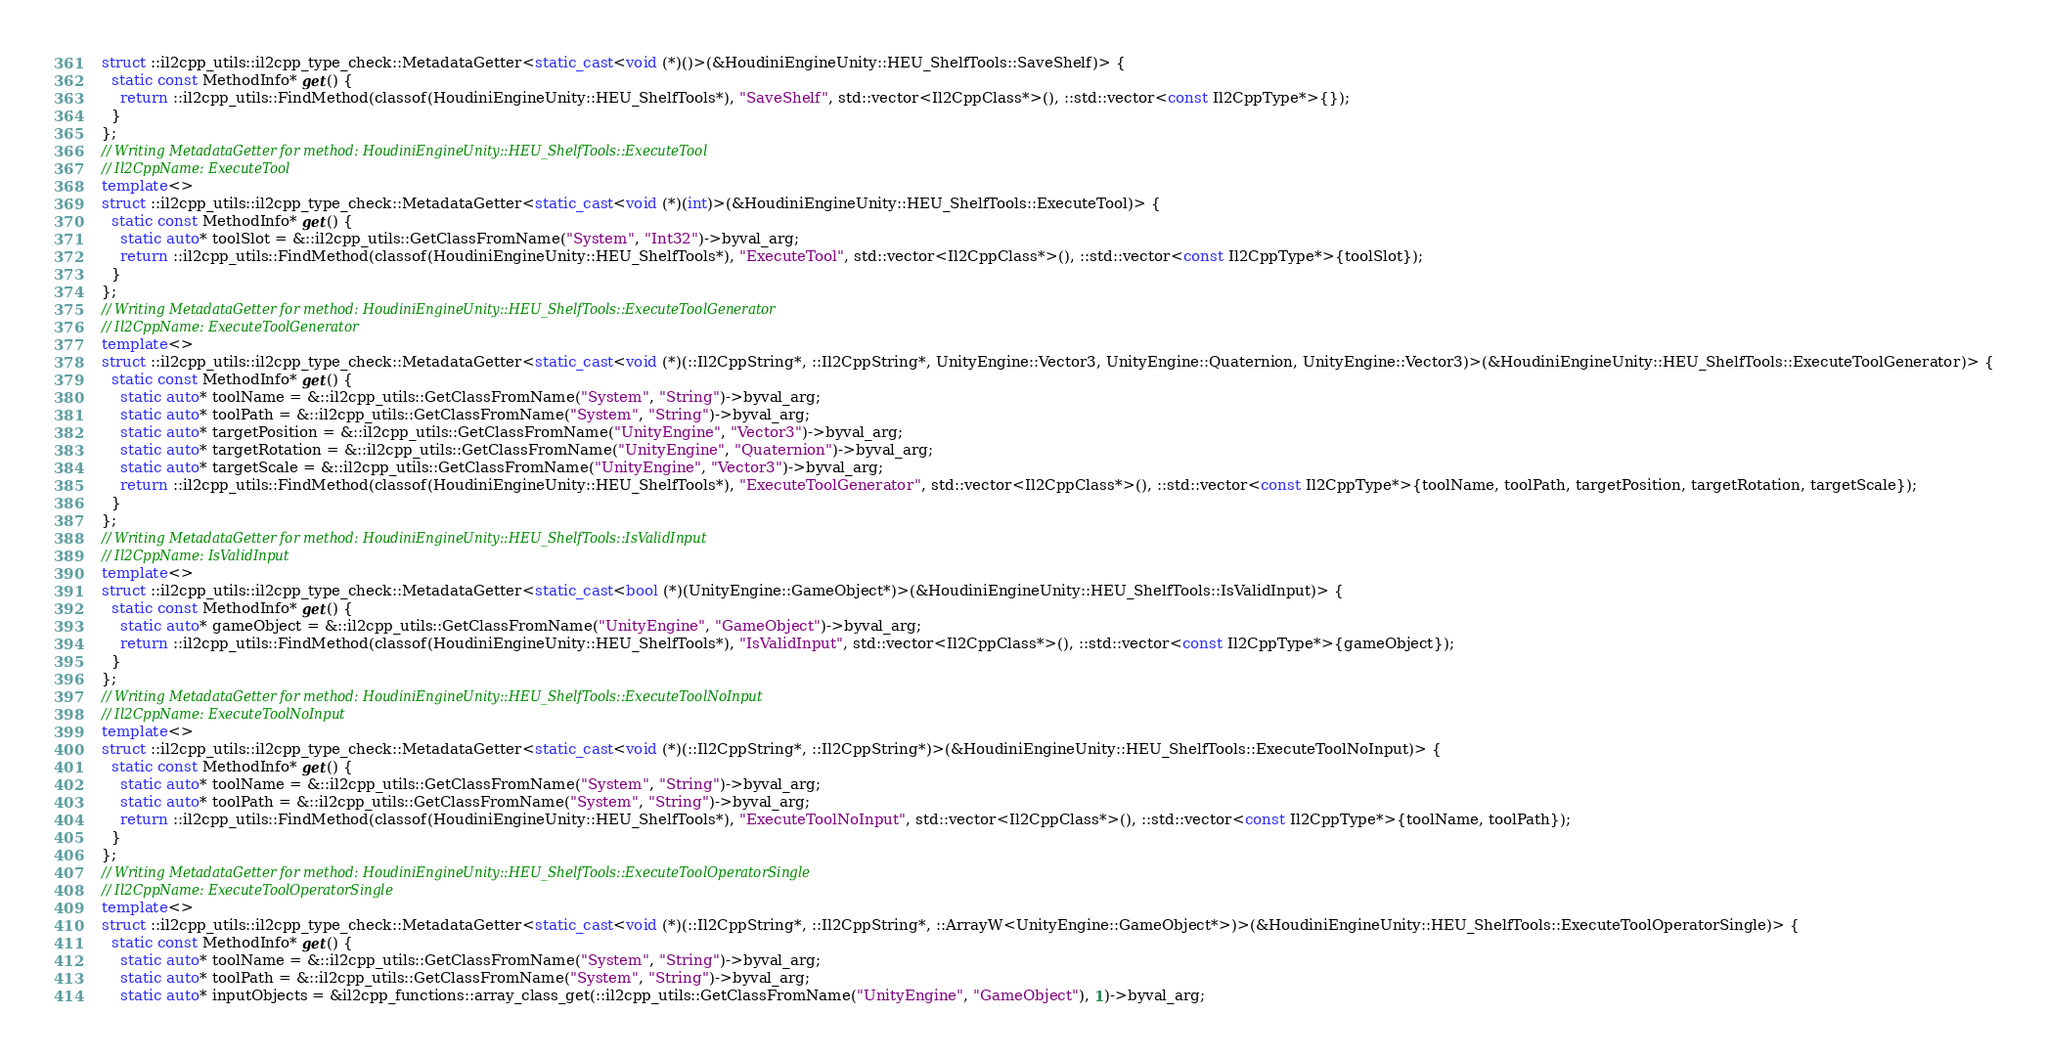<code> <loc_0><loc_0><loc_500><loc_500><_C++_>struct ::il2cpp_utils::il2cpp_type_check::MetadataGetter<static_cast<void (*)()>(&HoudiniEngineUnity::HEU_ShelfTools::SaveShelf)> {
  static const MethodInfo* get() {
    return ::il2cpp_utils::FindMethod(classof(HoudiniEngineUnity::HEU_ShelfTools*), "SaveShelf", std::vector<Il2CppClass*>(), ::std::vector<const Il2CppType*>{});
  }
};
// Writing MetadataGetter for method: HoudiniEngineUnity::HEU_ShelfTools::ExecuteTool
// Il2CppName: ExecuteTool
template<>
struct ::il2cpp_utils::il2cpp_type_check::MetadataGetter<static_cast<void (*)(int)>(&HoudiniEngineUnity::HEU_ShelfTools::ExecuteTool)> {
  static const MethodInfo* get() {
    static auto* toolSlot = &::il2cpp_utils::GetClassFromName("System", "Int32")->byval_arg;
    return ::il2cpp_utils::FindMethod(classof(HoudiniEngineUnity::HEU_ShelfTools*), "ExecuteTool", std::vector<Il2CppClass*>(), ::std::vector<const Il2CppType*>{toolSlot});
  }
};
// Writing MetadataGetter for method: HoudiniEngineUnity::HEU_ShelfTools::ExecuteToolGenerator
// Il2CppName: ExecuteToolGenerator
template<>
struct ::il2cpp_utils::il2cpp_type_check::MetadataGetter<static_cast<void (*)(::Il2CppString*, ::Il2CppString*, UnityEngine::Vector3, UnityEngine::Quaternion, UnityEngine::Vector3)>(&HoudiniEngineUnity::HEU_ShelfTools::ExecuteToolGenerator)> {
  static const MethodInfo* get() {
    static auto* toolName = &::il2cpp_utils::GetClassFromName("System", "String")->byval_arg;
    static auto* toolPath = &::il2cpp_utils::GetClassFromName("System", "String")->byval_arg;
    static auto* targetPosition = &::il2cpp_utils::GetClassFromName("UnityEngine", "Vector3")->byval_arg;
    static auto* targetRotation = &::il2cpp_utils::GetClassFromName("UnityEngine", "Quaternion")->byval_arg;
    static auto* targetScale = &::il2cpp_utils::GetClassFromName("UnityEngine", "Vector3")->byval_arg;
    return ::il2cpp_utils::FindMethod(classof(HoudiniEngineUnity::HEU_ShelfTools*), "ExecuteToolGenerator", std::vector<Il2CppClass*>(), ::std::vector<const Il2CppType*>{toolName, toolPath, targetPosition, targetRotation, targetScale});
  }
};
// Writing MetadataGetter for method: HoudiniEngineUnity::HEU_ShelfTools::IsValidInput
// Il2CppName: IsValidInput
template<>
struct ::il2cpp_utils::il2cpp_type_check::MetadataGetter<static_cast<bool (*)(UnityEngine::GameObject*)>(&HoudiniEngineUnity::HEU_ShelfTools::IsValidInput)> {
  static const MethodInfo* get() {
    static auto* gameObject = &::il2cpp_utils::GetClassFromName("UnityEngine", "GameObject")->byval_arg;
    return ::il2cpp_utils::FindMethod(classof(HoudiniEngineUnity::HEU_ShelfTools*), "IsValidInput", std::vector<Il2CppClass*>(), ::std::vector<const Il2CppType*>{gameObject});
  }
};
// Writing MetadataGetter for method: HoudiniEngineUnity::HEU_ShelfTools::ExecuteToolNoInput
// Il2CppName: ExecuteToolNoInput
template<>
struct ::il2cpp_utils::il2cpp_type_check::MetadataGetter<static_cast<void (*)(::Il2CppString*, ::Il2CppString*)>(&HoudiniEngineUnity::HEU_ShelfTools::ExecuteToolNoInput)> {
  static const MethodInfo* get() {
    static auto* toolName = &::il2cpp_utils::GetClassFromName("System", "String")->byval_arg;
    static auto* toolPath = &::il2cpp_utils::GetClassFromName("System", "String")->byval_arg;
    return ::il2cpp_utils::FindMethod(classof(HoudiniEngineUnity::HEU_ShelfTools*), "ExecuteToolNoInput", std::vector<Il2CppClass*>(), ::std::vector<const Il2CppType*>{toolName, toolPath});
  }
};
// Writing MetadataGetter for method: HoudiniEngineUnity::HEU_ShelfTools::ExecuteToolOperatorSingle
// Il2CppName: ExecuteToolOperatorSingle
template<>
struct ::il2cpp_utils::il2cpp_type_check::MetadataGetter<static_cast<void (*)(::Il2CppString*, ::Il2CppString*, ::ArrayW<UnityEngine::GameObject*>)>(&HoudiniEngineUnity::HEU_ShelfTools::ExecuteToolOperatorSingle)> {
  static const MethodInfo* get() {
    static auto* toolName = &::il2cpp_utils::GetClassFromName("System", "String")->byval_arg;
    static auto* toolPath = &::il2cpp_utils::GetClassFromName("System", "String")->byval_arg;
    static auto* inputObjects = &il2cpp_functions::array_class_get(::il2cpp_utils::GetClassFromName("UnityEngine", "GameObject"), 1)->byval_arg;</code> 